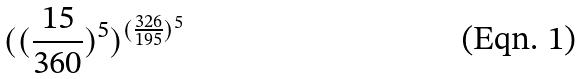<formula> <loc_0><loc_0><loc_500><loc_500>( ( \frac { 1 5 } { 3 6 0 } ) ^ { 5 } ) ^ { ( \frac { 3 2 6 } { 1 9 5 } ) ^ { 5 } }</formula> 